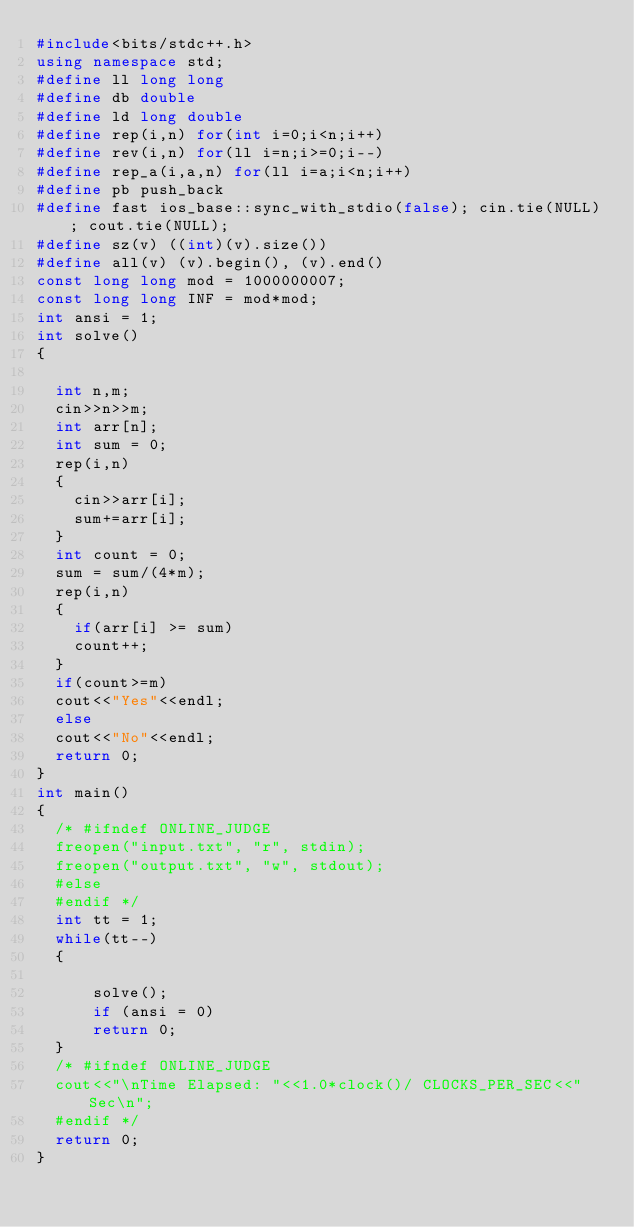Convert code to text. <code><loc_0><loc_0><loc_500><loc_500><_C++_>#include<bits/stdc++.h>
using namespace std;
#define ll long long
#define db double
#define ld long double
#define rep(i,n) for(int i=0;i<n;i++)
#define rev(i,n) for(ll i=n;i>=0;i--)
#define rep_a(i,a,n) for(ll i=a;i<n;i++)
#define pb push_back
#define fast ios_base::sync_with_stdio(false); cin.tie(NULL); cout.tie(NULL);
#define sz(v) ((int)(v).size())
#define all(v) (v).begin(), (v).end()
const long long mod = 1000000007;
const long long INF = mod*mod;
int ansi = 1;
int solve()
{
	
	int n,m;
	cin>>n>>m;
	int arr[n];
	int sum = 0;
	rep(i,n)
	{
		cin>>arr[i];
		sum+=arr[i];
	}
	int count = 0;
	sum = sum/(4*m);
	rep(i,n)
	{
		if(arr[i] >= sum)
		count++;
	}
	if(count>=m)
	cout<<"Yes"<<endl;
	else
	cout<<"No"<<endl;
	return 0;
}
int main()
{
	/* #ifndef ONLINE_JUDGE
	freopen("input.txt", "r", stdin);
	freopen("output.txt", "w", stdout);
	#else
	#endif */
	int tt = 1;
	while(tt--)
	{
	   
	    solve();
	    if (ansi = 0)
	    return 0;
	}
	/* #ifndef ONLINE_JUDGE
	cout<<"\nTime Elapsed: "<<1.0*clock()/ CLOCKS_PER_SEC<<" Sec\n";
	#endif */
	return 0;
}
</code> 